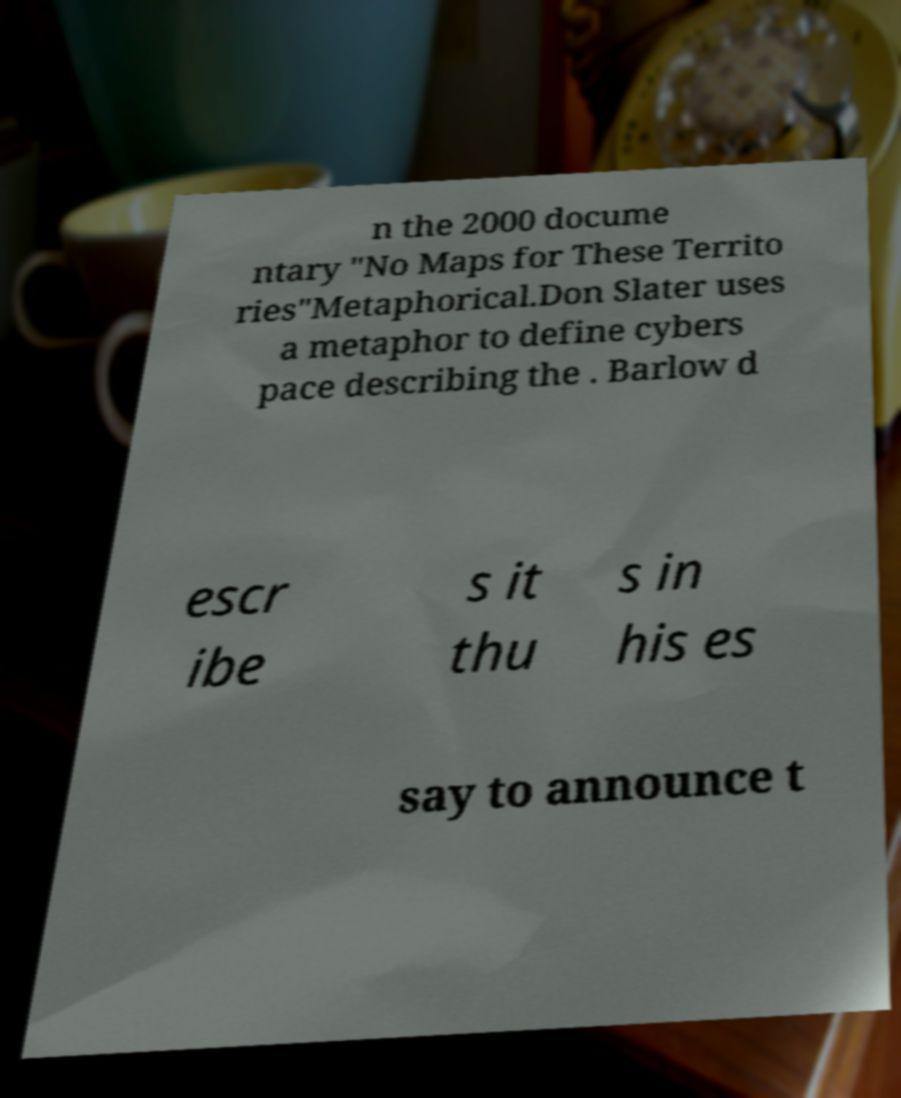Can you read and provide the text displayed in the image?This photo seems to have some interesting text. Can you extract and type it out for me? n the 2000 docume ntary "No Maps for These Territo ries"Metaphorical.Don Slater uses a metaphor to define cybers pace describing the . Barlow d escr ibe s it thu s in his es say to announce t 